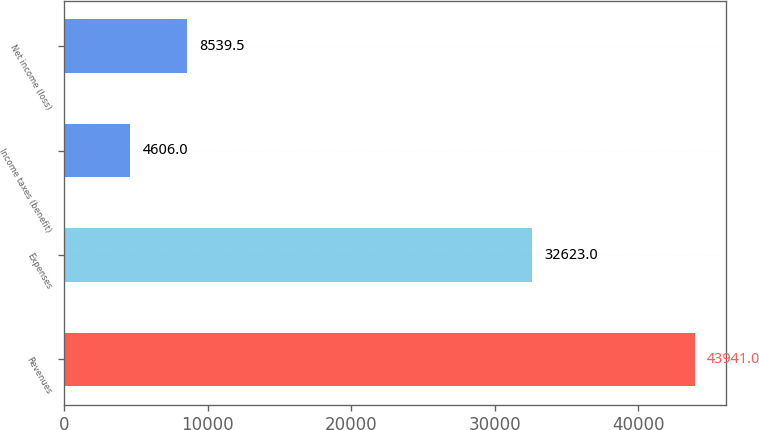Convert chart. <chart><loc_0><loc_0><loc_500><loc_500><bar_chart><fcel>Revenues<fcel>Expenses<fcel>Income taxes (benefit)<fcel>Net income (loss)<nl><fcel>43941<fcel>32623<fcel>4606<fcel>8539.5<nl></chart> 